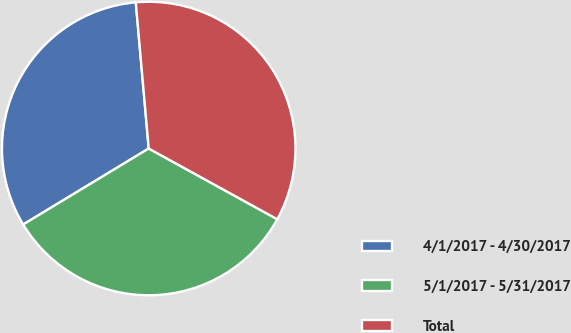Convert chart. <chart><loc_0><loc_0><loc_500><loc_500><pie_chart><fcel>4/1/2017 - 4/30/2017<fcel>5/1/2017 - 5/31/2017<fcel>Total<nl><fcel>32.26%<fcel>33.33%<fcel>34.41%<nl></chart> 